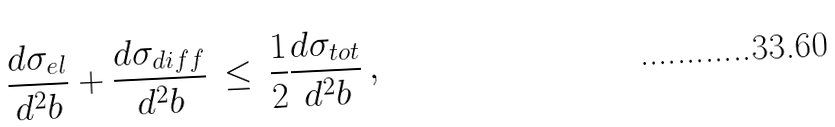<formula> <loc_0><loc_0><loc_500><loc_500>\frac { d \sigma _ { e l } } { d ^ { 2 } b } + \frac { d \sigma _ { d i f f } } { d ^ { 2 } b } \, \leq \, \frac { 1 } { 2 } \frac { d \sigma _ { t o t } } { d ^ { 2 } b } \, ,</formula> 